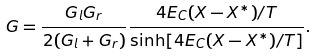Convert formula to latex. <formula><loc_0><loc_0><loc_500><loc_500>G = \frac { G _ { l } G _ { r } } { 2 ( G _ { l } + G _ { r } ) } \frac { 4 E _ { C } ( X - X ^ { * } ) / T } { \sinh [ 4 E _ { C } ( X - X ^ { * } ) / T ] } .</formula> 